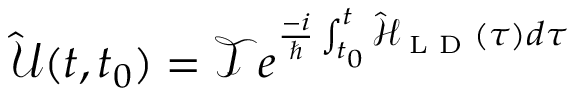Convert formula to latex. <formula><loc_0><loc_0><loc_500><loc_500>\mathcal { \hat { U } } ( t , t _ { 0 } ) = \mathcal { T } e ^ { \frac { - i } { } \int _ { t _ { 0 } } ^ { t } \mathcal { \hat { H } } _ { L D } ( \tau ) d \tau }</formula> 